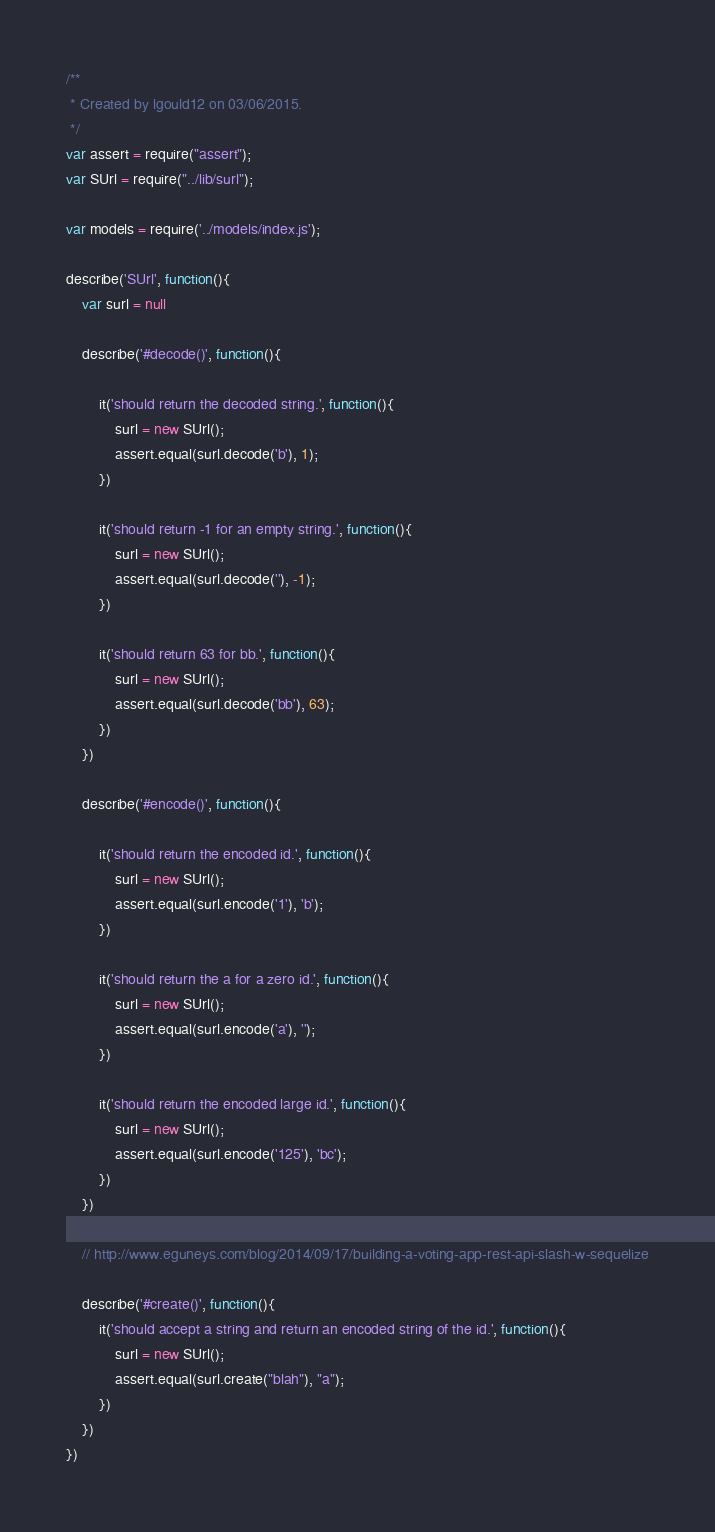<code> <loc_0><loc_0><loc_500><loc_500><_JavaScript_>/**
 * Created by lgould12 on 03/06/2015.
 */
var assert = require("assert");
var SUrl = require("../lib/surl");

var models = require('../models/index.js');

describe('SUrl', function(){
    var surl = null

    describe('#decode()', function(){

        it('should return the decoded string.', function(){
            surl = new SUrl();
            assert.equal(surl.decode('b'), 1);
        })

        it('should return -1 for an empty string.', function(){
            surl = new SUrl();
            assert.equal(surl.decode(''), -1);
        })

        it('should return 63 for bb.', function(){
            surl = new SUrl();
            assert.equal(surl.decode('bb'), 63);
        })
    })

    describe('#encode()', function(){

        it('should return the encoded id.', function(){
            surl = new SUrl();
            assert.equal(surl.encode('1'), 'b');
        })

        it('should return the a for a zero id.', function(){
            surl = new SUrl();
            assert.equal(surl.encode('a'), '');
        })

        it('should return the encoded large id.', function(){
            surl = new SUrl();
            assert.equal(surl.encode('125'), 'bc');
        })
    })

    // http://www.eguneys.com/blog/2014/09/17/building-a-voting-app-rest-api-slash-w-sequelize

    describe('#create()', function(){
        it('should accept a string and return an encoded string of the id.', function(){
            surl = new SUrl();
            assert.equal(surl.create("blah"), "a");
        })
    })
})



</code> 